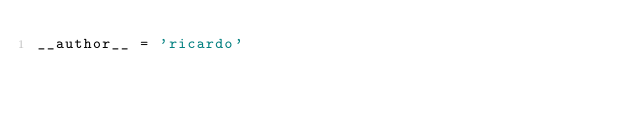<code> <loc_0><loc_0><loc_500><loc_500><_Python_>__author__ = 'ricardo'
</code> 